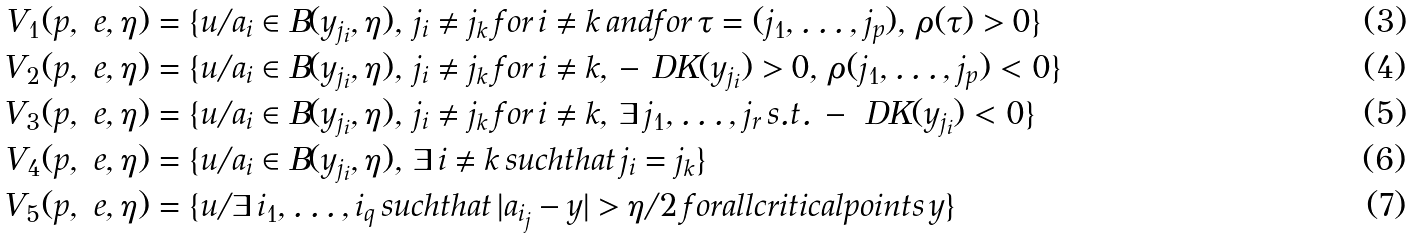Convert formula to latex. <formula><loc_0><loc_0><loc_500><loc_500>V _ { 1 } ( p , \ e , \eta ) & = \{ u / a _ { i } \in B ( y _ { j _ { i } } , \eta ) , \, j _ { i } \ne j _ { k } \, f o r \, i \ne k \, a n d f o r \, \tau = ( j _ { 1 } , \dots , j _ { p } ) , \, \rho ( \tau ) > 0 \} \\ V _ { 2 } ( p , \ e , \eta ) & = \{ u / a _ { i } \in B ( y _ { j _ { i } } , \eta ) , \, j _ { i } \ne j _ { k } \, f o r \, i \ne k , \, - \ D K ( y _ { j _ { i } } ) > 0 , \, \rho ( j _ { 1 } , \dots , j _ { p } ) < 0 \} \\ V _ { 3 } ( p , \ e , \eta ) & = \{ u / a _ { i } \in B ( y _ { j _ { i } } , \eta ) , \, j _ { i } \ne j _ { k } \, f o r \, i \ne k , \, \exists \, j _ { 1 } , \dots , j _ { r } \, s . t . \, - \ D K ( y _ { j _ { i } } ) < 0 \} \\ V _ { 4 } ( p , \ e , \eta ) & = \{ u / a _ { i } \in B ( y _ { j _ { i } } , \eta ) , \, \exists \, i \ne k \, s u c h t h a t \, j _ { i } = j _ { k } \} \\ V _ { 5 } ( p , \ e , \eta ) & = \{ u / \exists \, i _ { 1 } , \dots , i _ { q } \, s u c h t h a t \, | a _ { i _ { j } } - y | > \eta / 2 \, f o r a l l c r i t i c a l p o i n t s \, y \}</formula> 